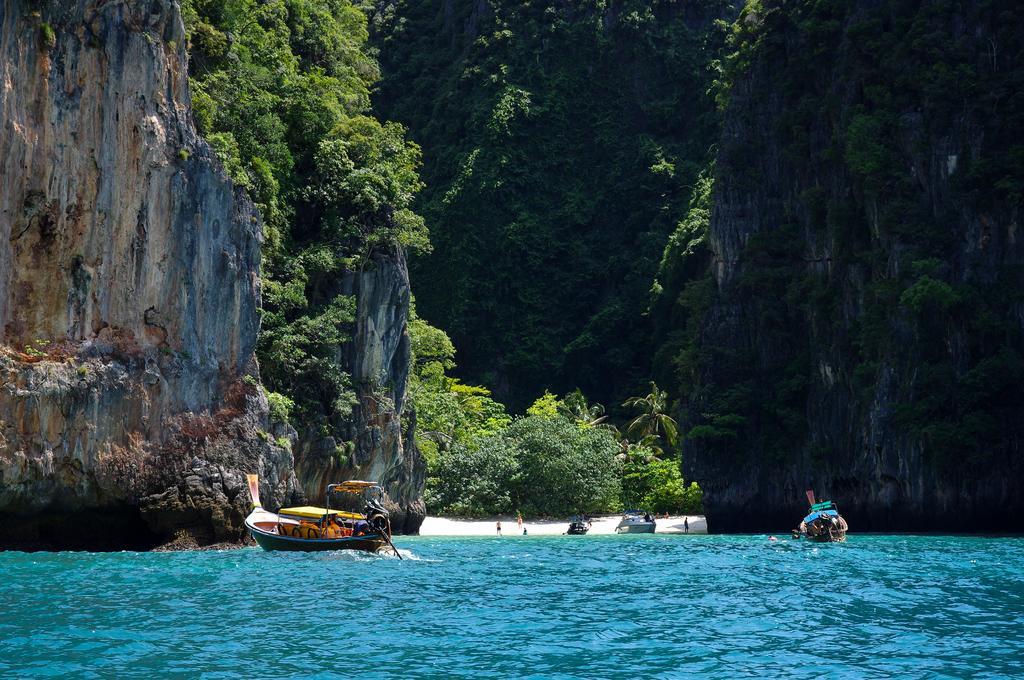Can you describe this image briefly? In this picture there is a ocean with two ships on it. And in the background there are hills with many trees on it. In the middle there are many trees and some people on the sea shore with two boats. 